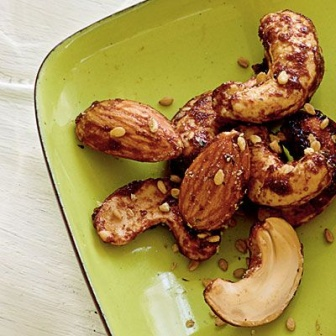Imagine we're creating a story where these nuts are characters. What kind of story could it be? Imagine a fantastical world where these nuts are brave adventurers on a quest to find the 'Spice of Eternity,' a legendary flavor said to bring an explosion of taste to anyone who finds it. The almond, known as Sir Almondine, is a seasoned knight with a rough exterior but a warm heart. Lady Cashewla is his trusty companion, agile and quick-witted, always ready with a clever plan. The duo embarks on their journey from the serene land of Plate Green, navigating through territories like the Cracked Pepper Woods and the Turmeric Caves. Along the way, they encounter allies such as the wise old Sesharegpt4v/same Sage and foes like the bitter Nutmeg Dragon. Their adventure is filled with trials and triumphs, ultimately leading them to discover that the true 'Spice of Eternity' was the friendship and camaraderie they developed along the way. 